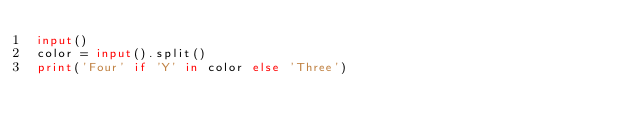Convert code to text. <code><loc_0><loc_0><loc_500><loc_500><_Python_>input()
color = input().split()
print('Four' if 'Y' in color else 'Three')</code> 